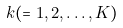Convert formula to latex. <formula><loc_0><loc_0><loc_500><loc_500>k ( = 1 , 2 , \dots , K )</formula> 